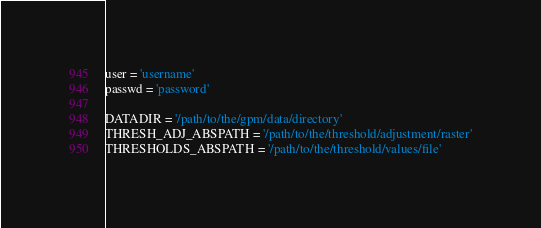<code> <loc_0><loc_0><loc_500><loc_500><_Python_>user = 'username'
passwd = 'password'

DATADIR = '/path/to/the/gpm/data/directory'
THRESH_ADJ_ABSPATH = '/path/to/the/threshold/adjustment/raster'
THRESHOLDS_ABSPATH = '/path/to/the/threshold/values/file'
</code> 